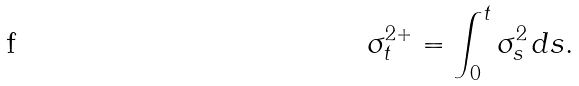<formula> <loc_0><loc_0><loc_500><loc_500>\sigma _ { t } ^ { 2 + } = \int _ { 0 } ^ { t } \sigma _ { s } ^ { 2 } \, d s .</formula> 